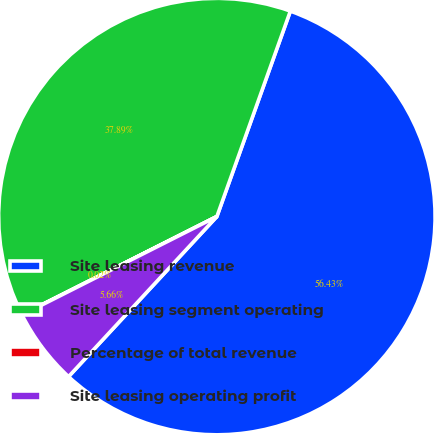<chart> <loc_0><loc_0><loc_500><loc_500><pie_chart><fcel>Site leasing revenue<fcel>Site leasing segment operating<fcel>Percentage of total revenue<fcel>Site leasing operating profit<nl><fcel>56.42%<fcel>37.89%<fcel>0.02%<fcel>5.66%<nl></chart> 